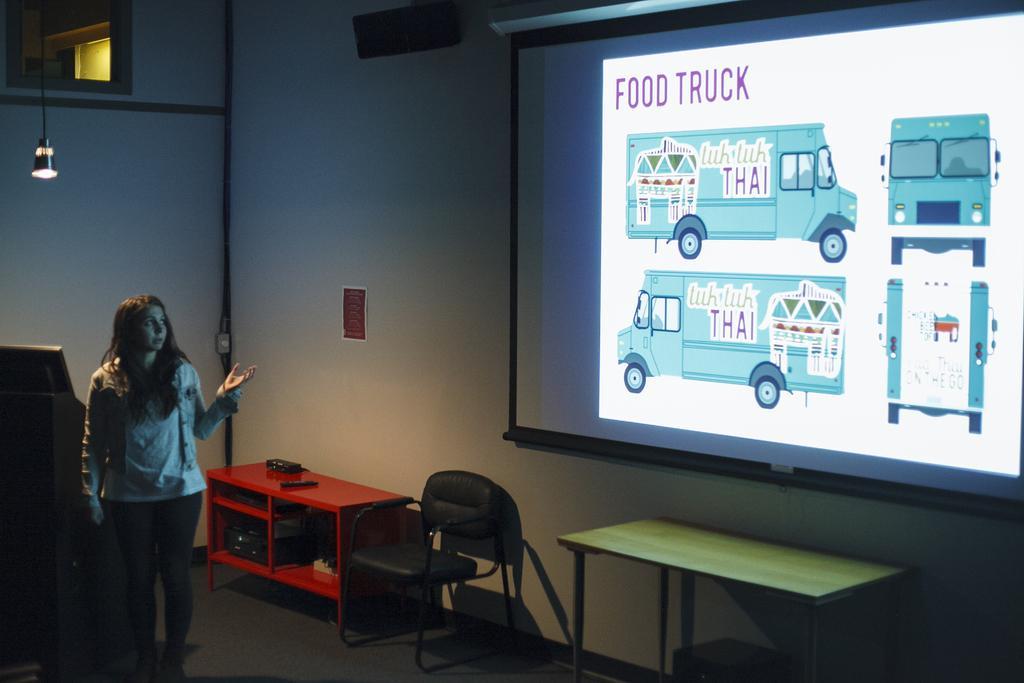Could you give a brief overview of what you see in this image? This picture shows a woman standing and seeing a projector screen and talking and we see a chair and couple of tables and light hanging to the roof 